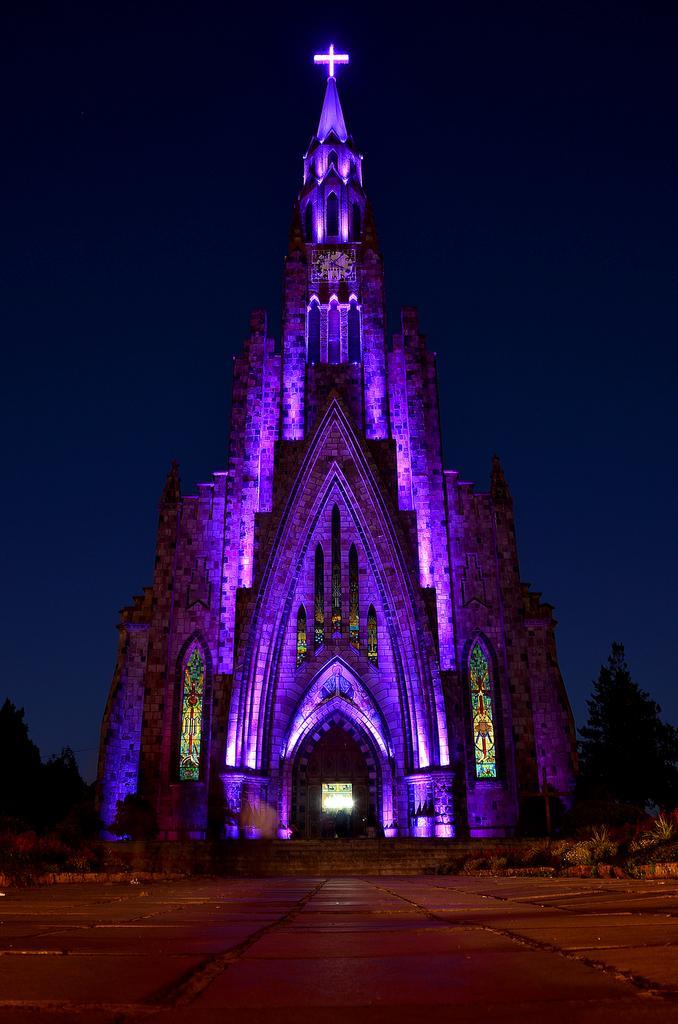Describe this image in one or two sentences. In this image we can see a building with windows. We can also see some lights, a staircase, some plants, trees and the sky. 